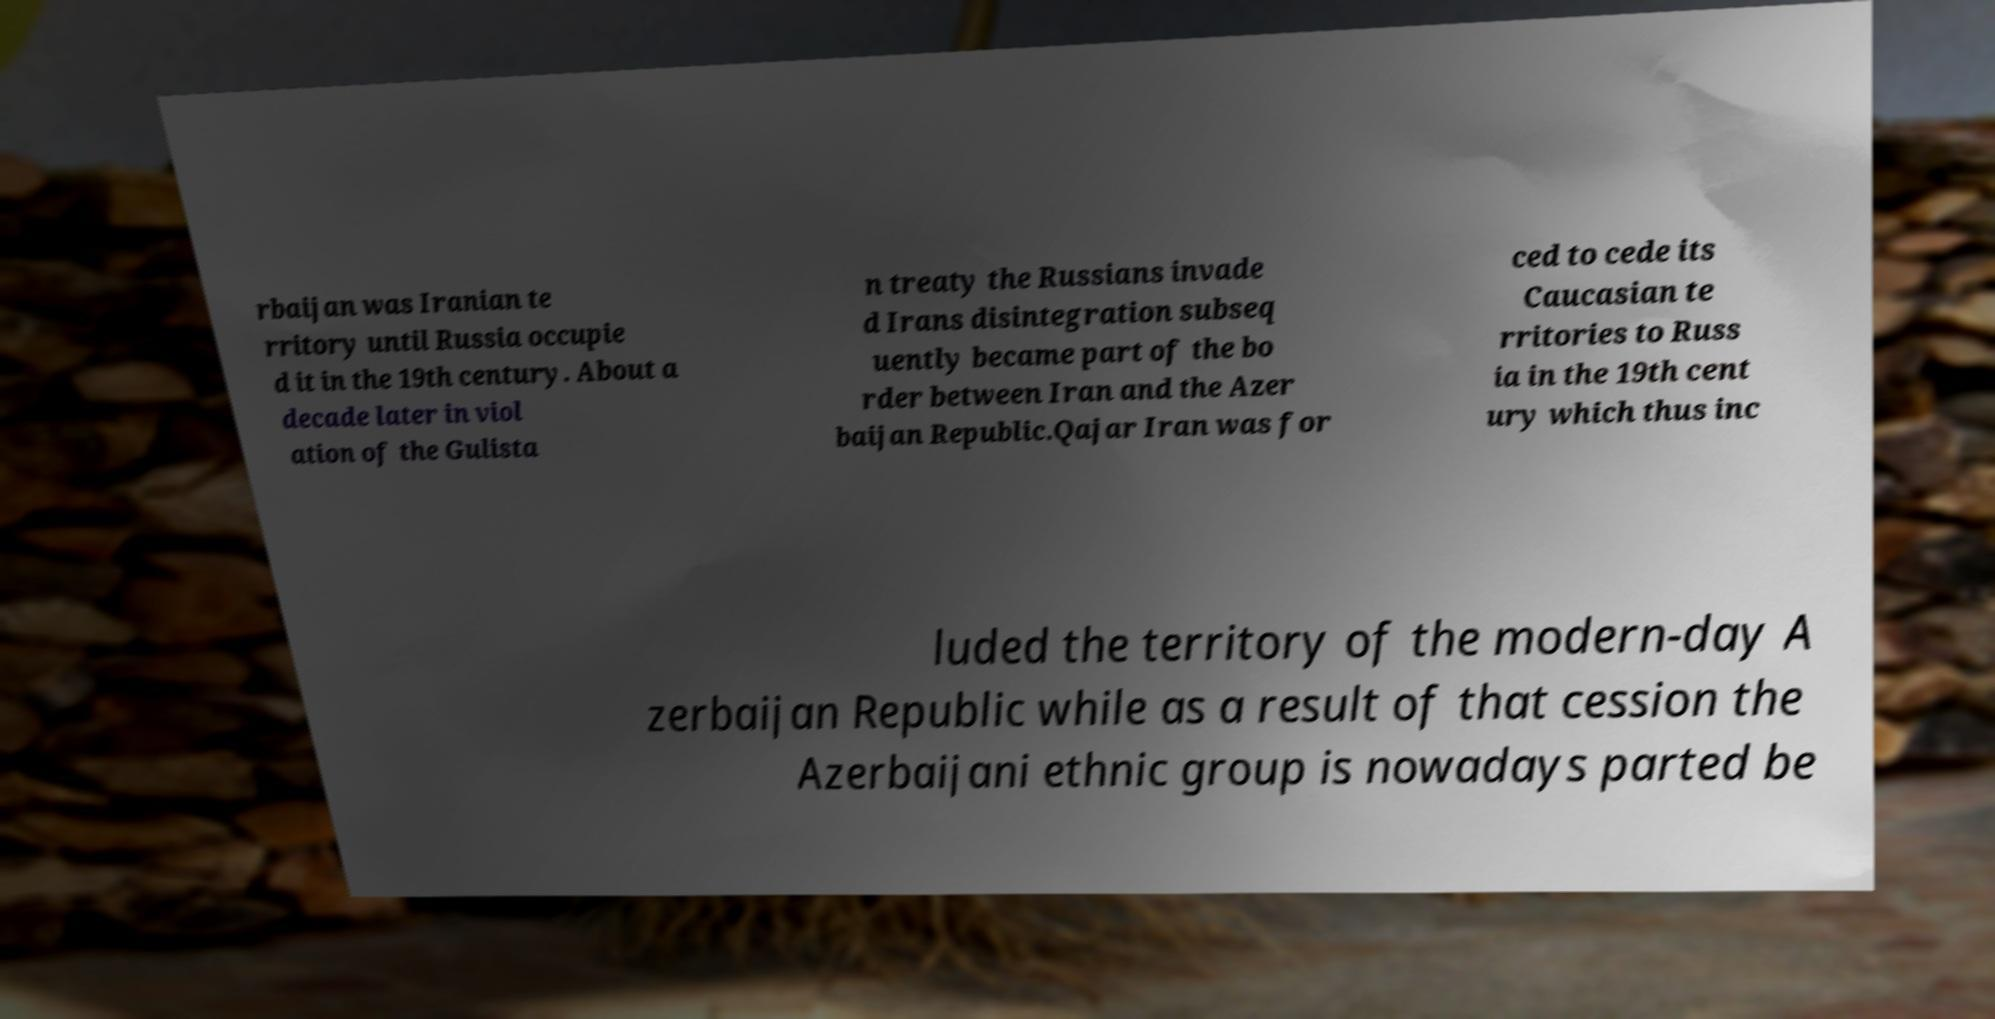Could you assist in decoding the text presented in this image and type it out clearly? rbaijan was Iranian te rritory until Russia occupie d it in the 19th century. About a decade later in viol ation of the Gulista n treaty the Russians invade d Irans disintegration subseq uently became part of the bo rder between Iran and the Azer baijan Republic.Qajar Iran was for ced to cede its Caucasian te rritories to Russ ia in the 19th cent ury which thus inc luded the territory of the modern-day A zerbaijan Republic while as a result of that cession the Azerbaijani ethnic group is nowadays parted be 